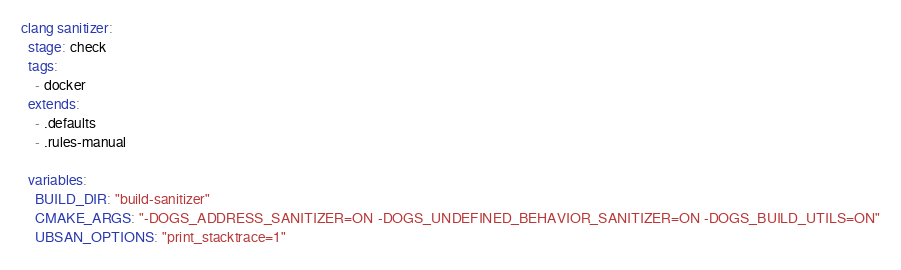Convert code to text. <code><loc_0><loc_0><loc_500><loc_500><_YAML_>clang sanitizer:
  stage: check
  tags:
    - docker
  extends:
    - .defaults
    - .rules-manual

  variables:
    BUILD_DIR: "build-sanitizer"
    CMAKE_ARGS: "-DOGS_ADDRESS_SANITIZER=ON -DOGS_UNDEFINED_BEHAVIOR_SANITIZER=ON -DOGS_BUILD_UTILS=ON"
    UBSAN_OPTIONS: "print_stacktrace=1"</code> 